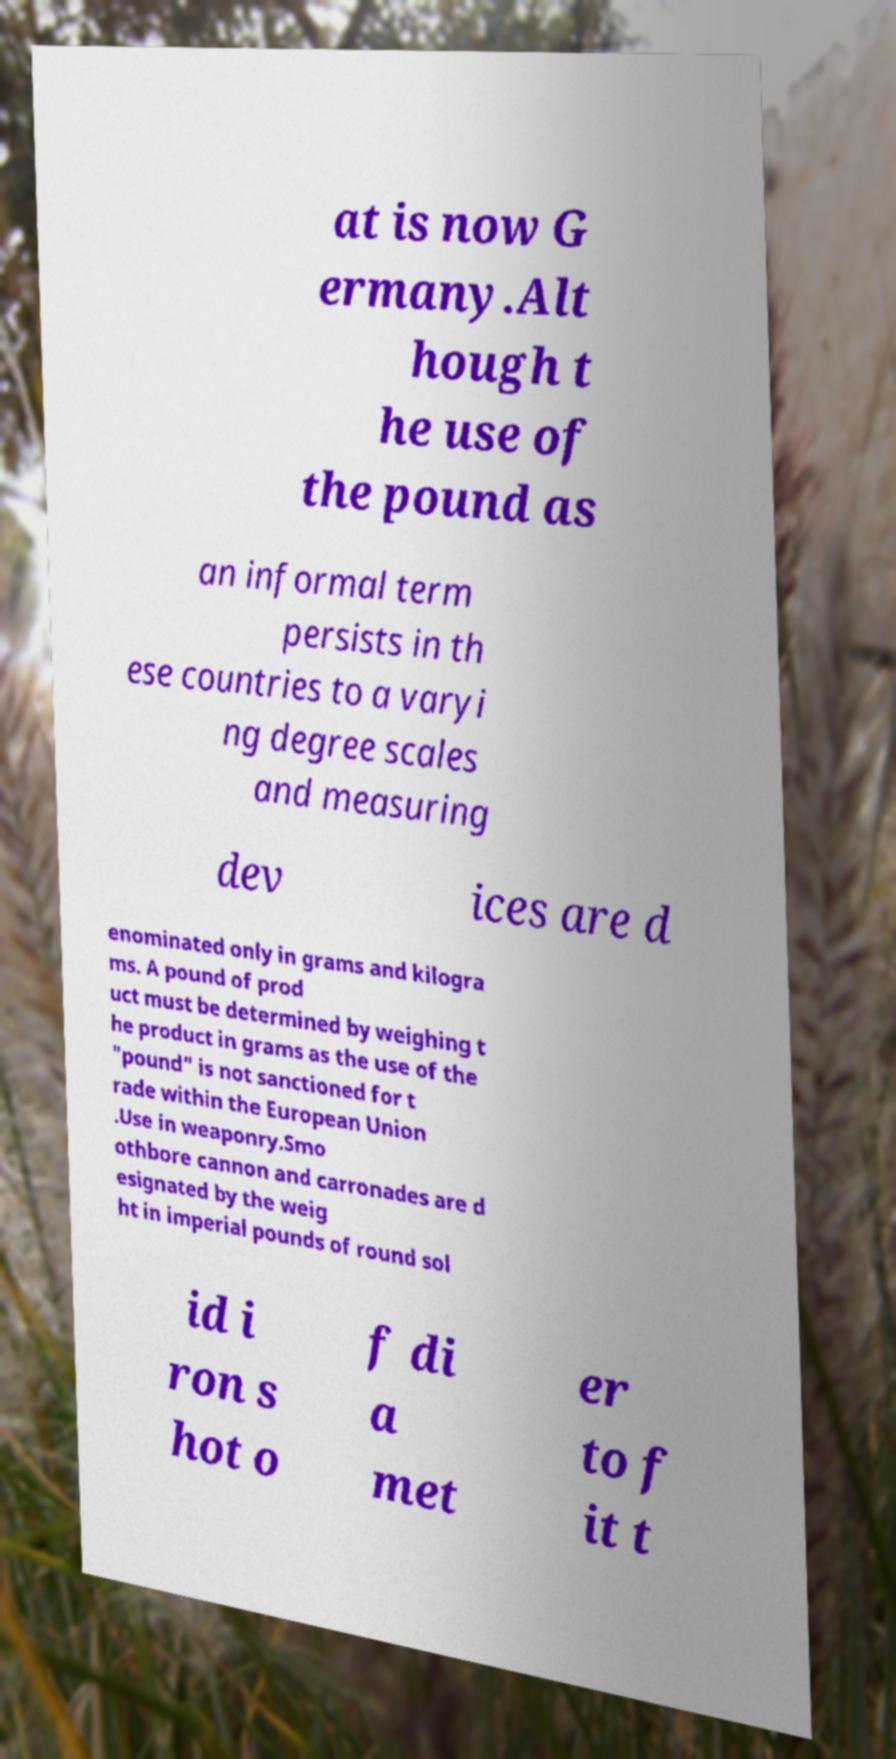What messages or text are displayed in this image? I need them in a readable, typed format. at is now G ermany.Alt hough t he use of the pound as an informal term persists in th ese countries to a varyi ng degree scales and measuring dev ices are d enominated only in grams and kilogra ms. A pound of prod uct must be determined by weighing t he product in grams as the use of the "pound" is not sanctioned for t rade within the European Union .Use in weaponry.Smo othbore cannon and carronades are d esignated by the weig ht in imperial pounds of round sol id i ron s hot o f di a met er to f it t 